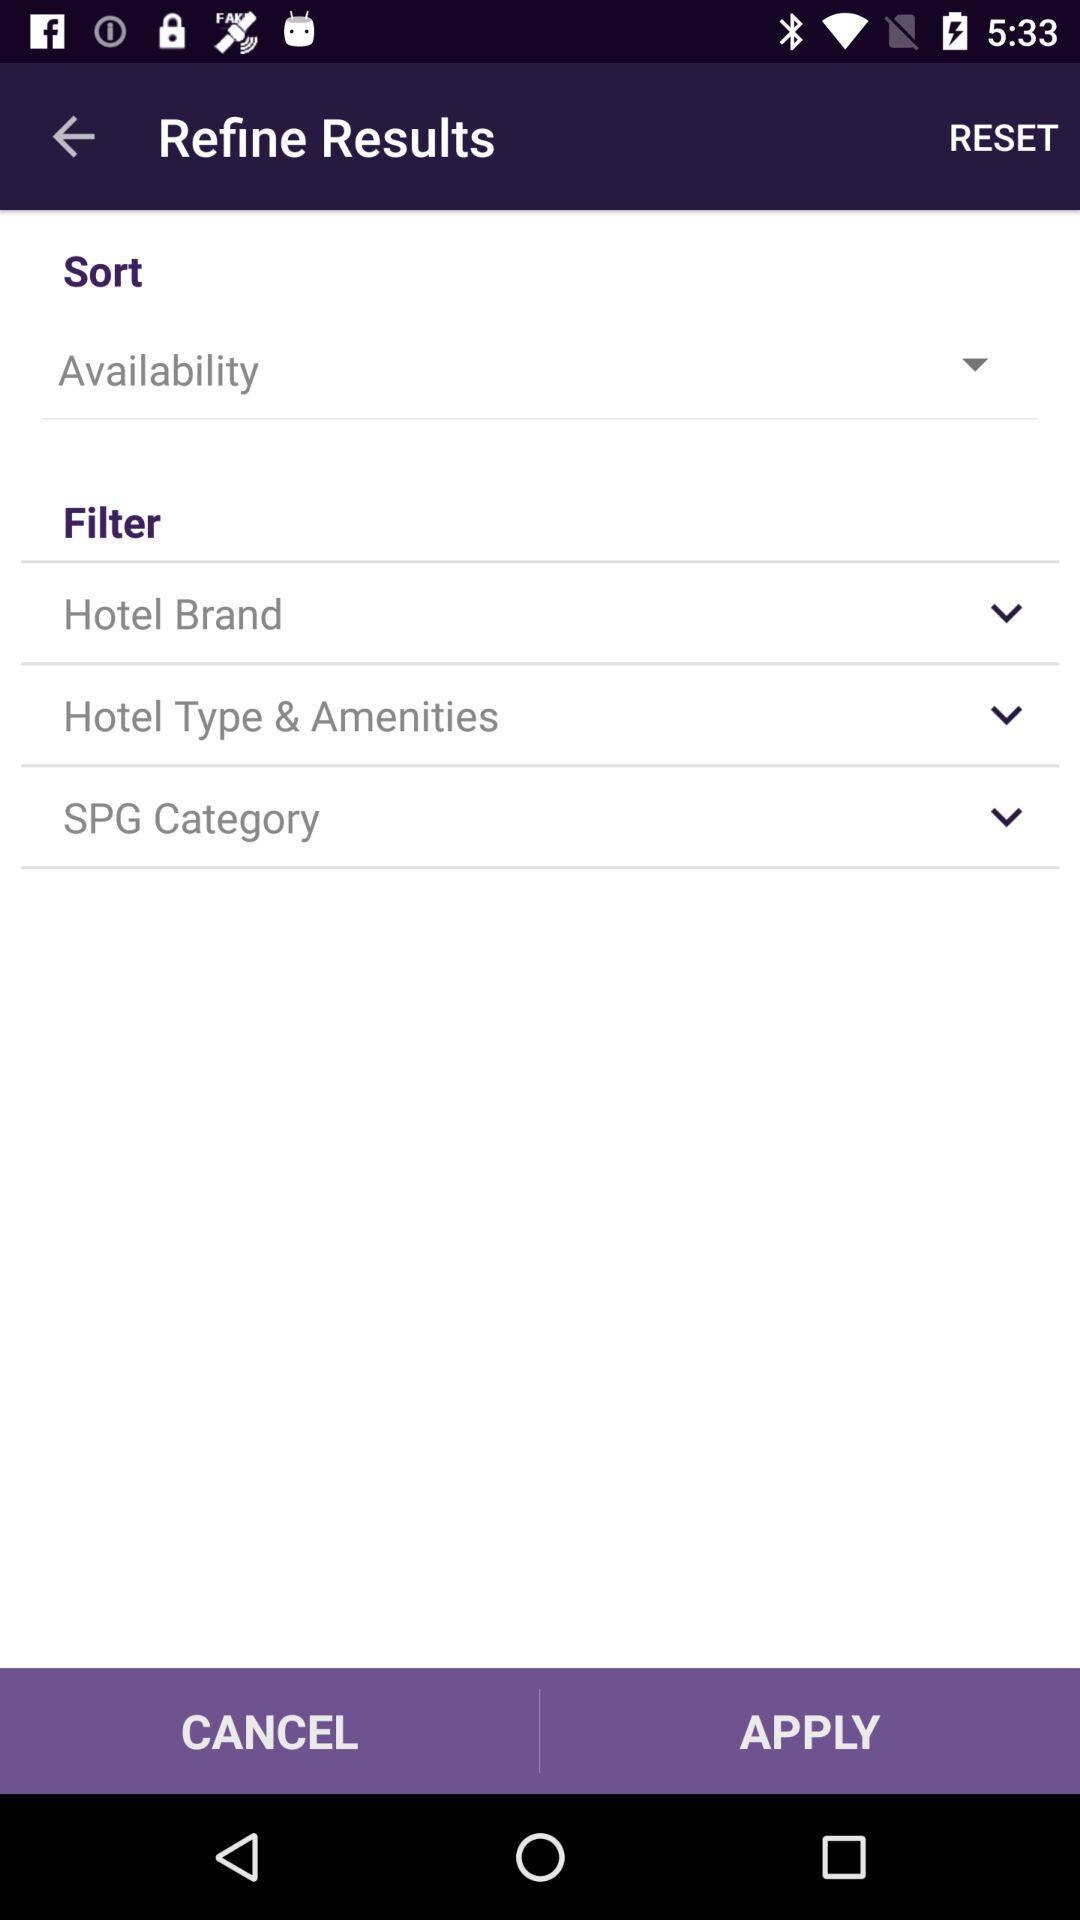What sort option is selected? The selected sort option is availability. 